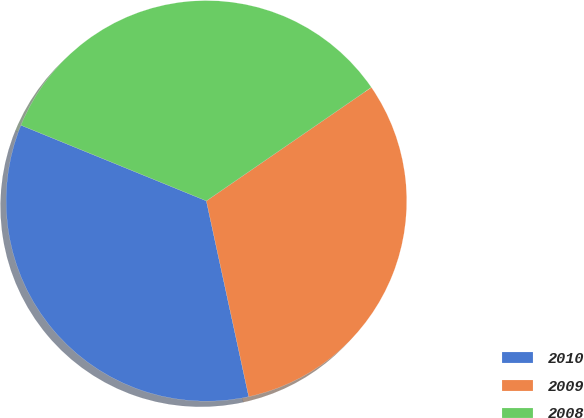<chart> <loc_0><loc_0><loc_500><loc_500><pie_chart><fcel>2010<fcel>2009<fcel>2008<nl><fcel>34.56%<fcel>31.2%<fcel>34.24%<nl></chart> 